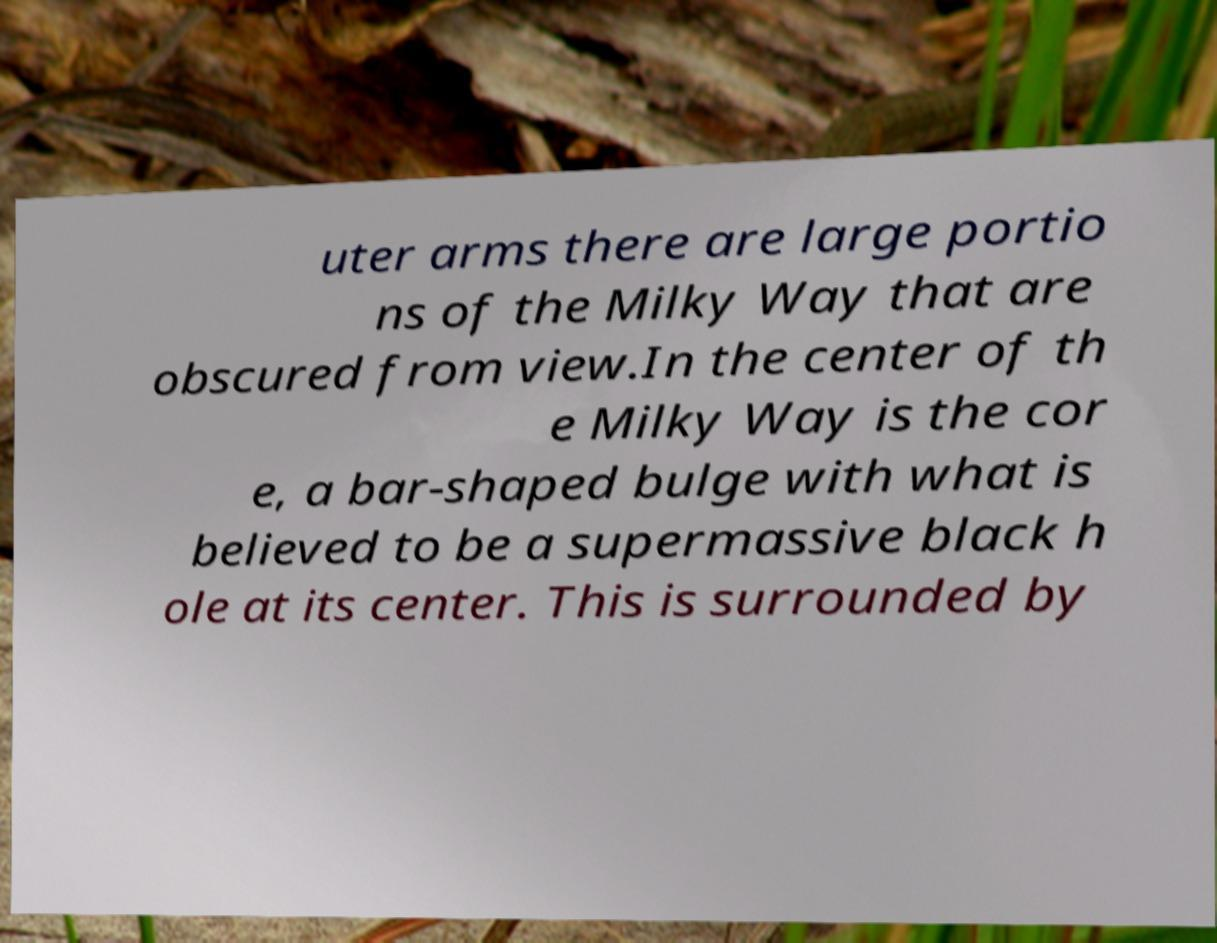For documentation purposes, I need the text within this image transcribed. Could you provide that? uter arms there are large portio ns of the Milky Way that are obscured from view.In the center of th e Milky Way is the cor e, a bar-shaped bulge with what is believed to be a supermassive black h ole at its center. This is surrounded by 